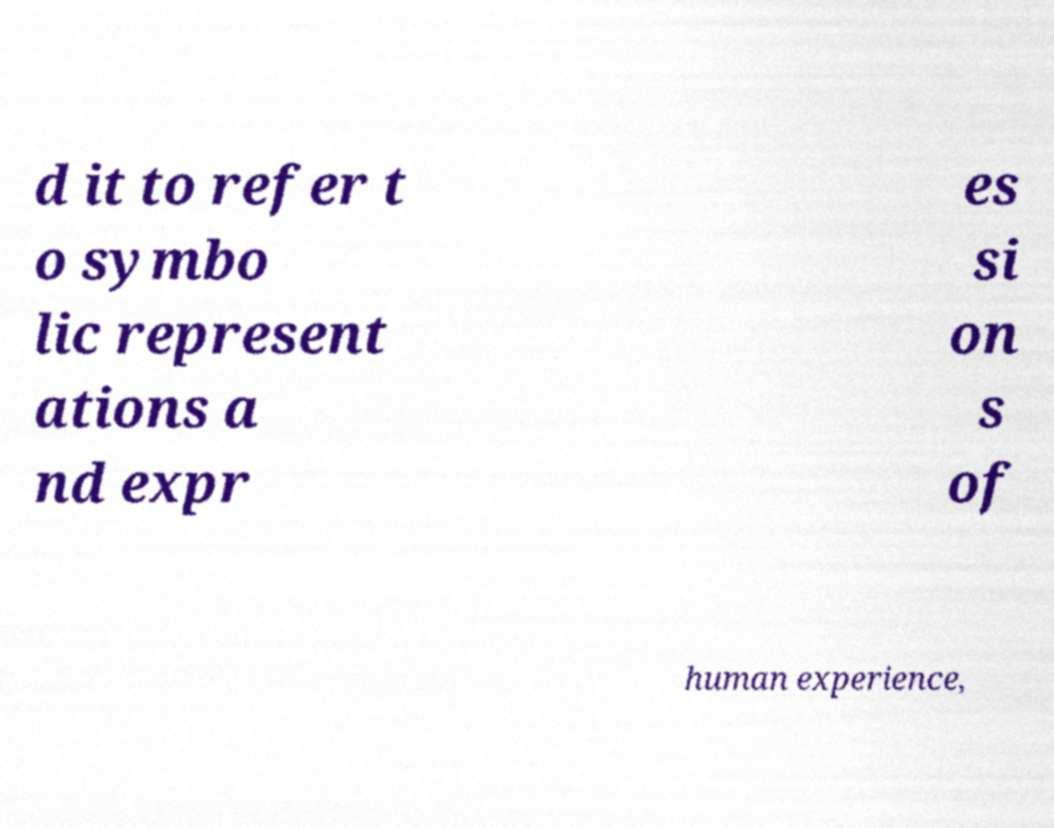There's text embedded in this image that I need extracted. Can you transcribe it verbatim? d it to refer t o symbo lic represent ations a nd expr es si on s of human experience, 